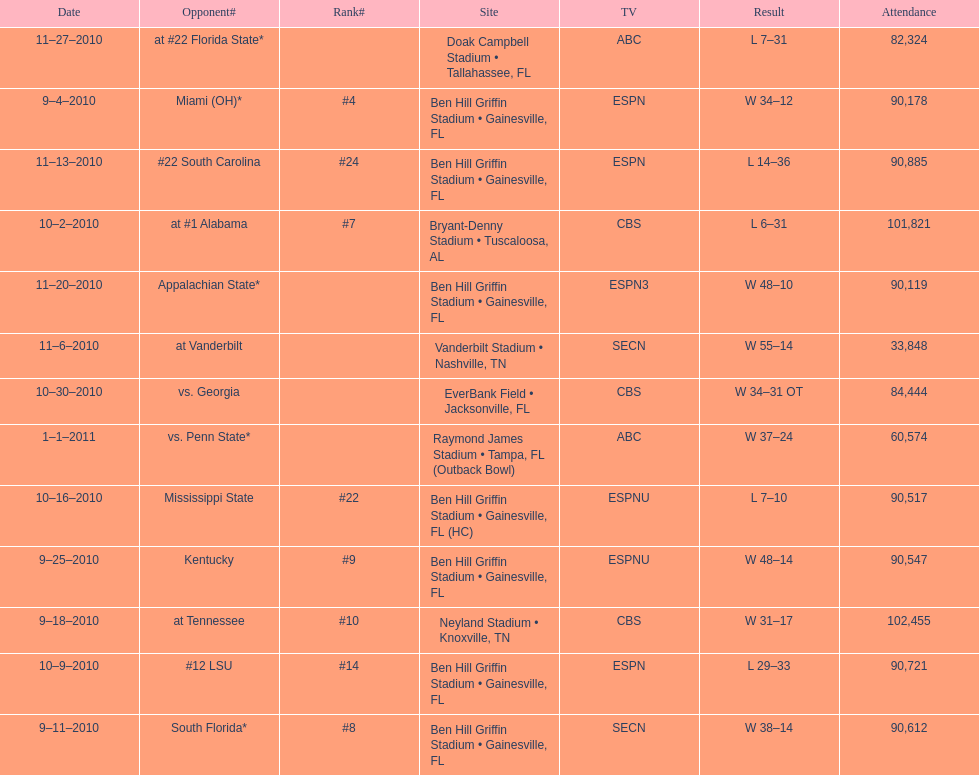How many games did the university of florida win by at least 10 points? 7. 